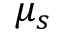<formula> <loc_0><loc_0><loc_500><loc_500>\mu _ { s }</formula> 